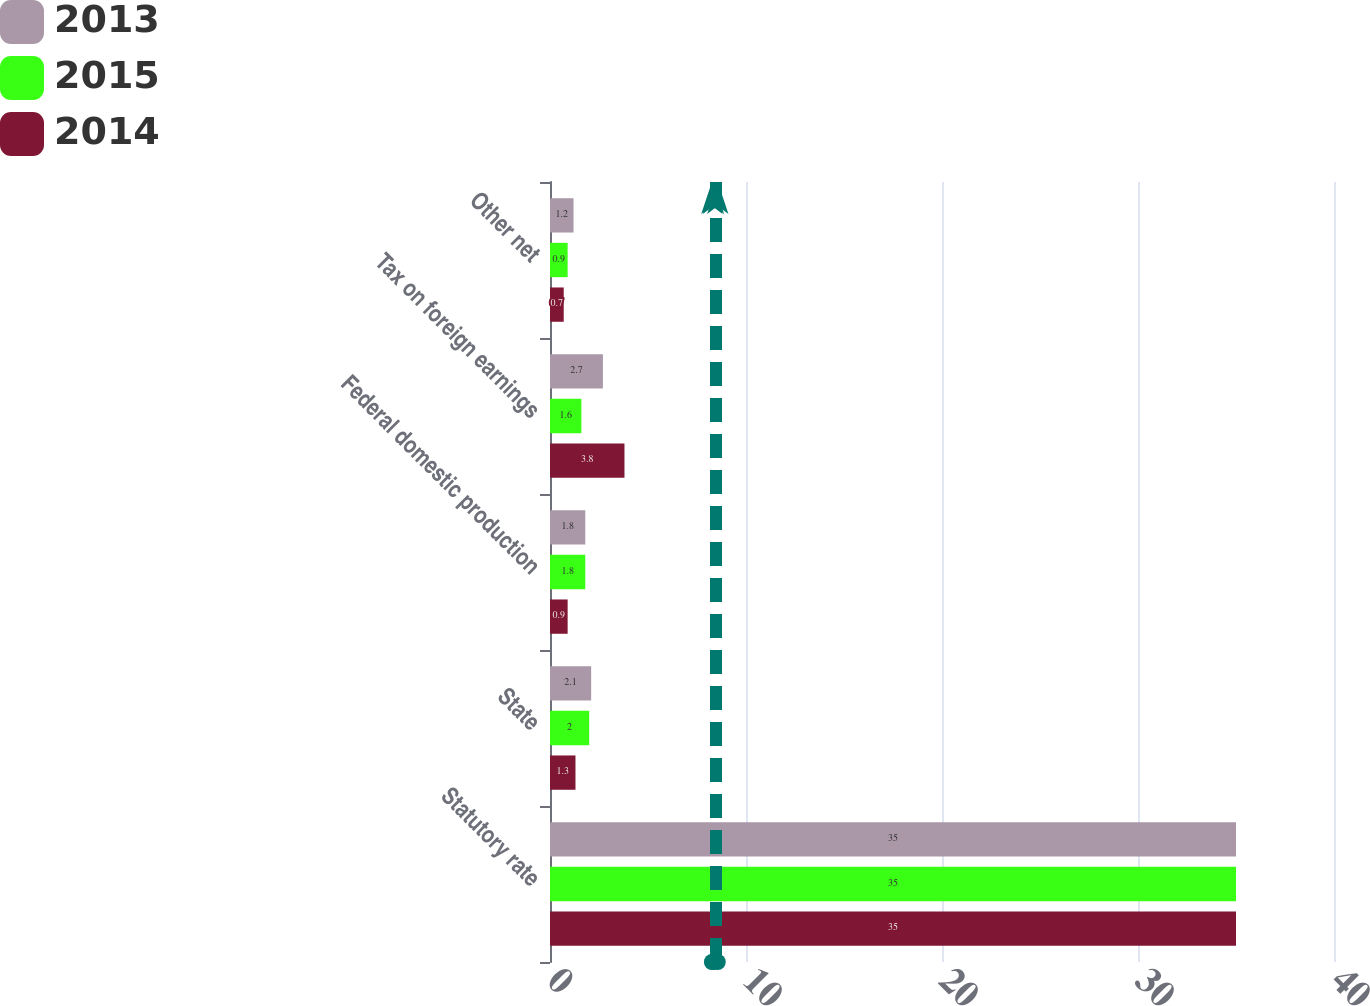Convert chart to OTSL. <chart><loc_0><loc_0><loc_500><loc_500><stacked_bar_chart><ecel><fcel>Statutory rate<fcel>State<fcel>Federal domestic production<fcel>Tax on foreign earnings<fcel>Other net<nl><fcel>2013<fcel>35<fcel>2.1<fcel>1.8<fcel>2.7<fcel>1.2<nl><fcel>2015<fcel>35<fcel>2<fcel>1.8<fcel>1.6<fcel>0.9<nl><fcel>2014<fcel>35<fcel>1.3<fcel>0.9<fcel>3.8<fcel>0.7<nl></chart> 